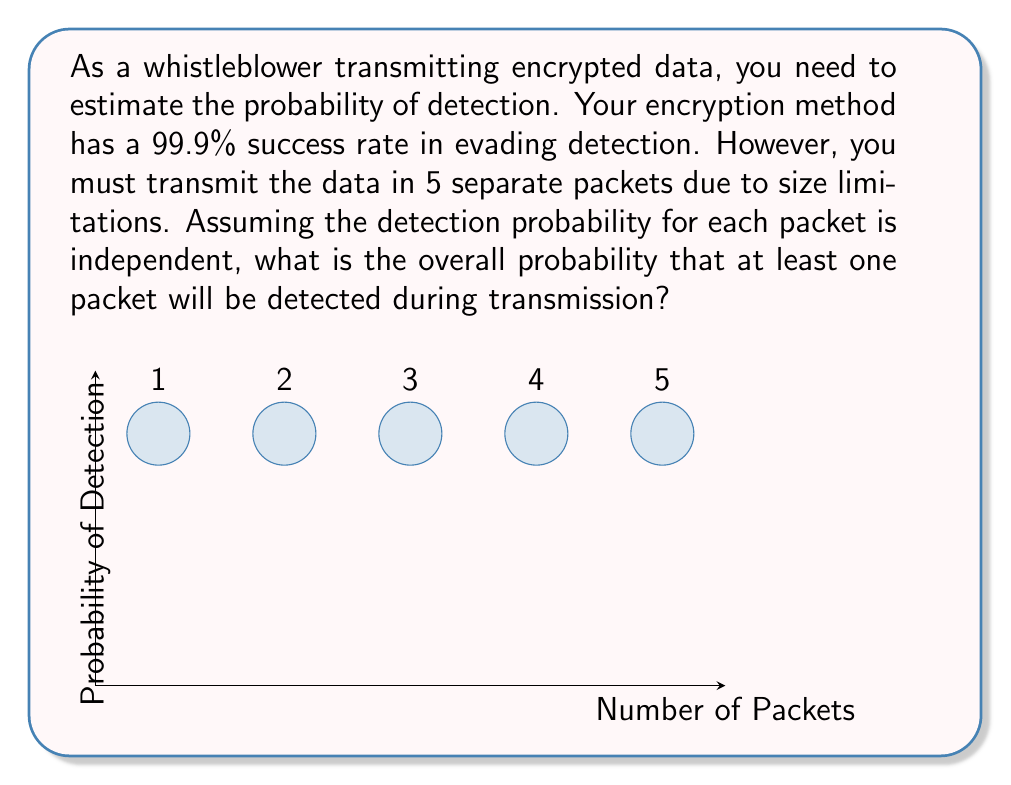Solve this math problem. Let's approach this step-by-step:

1) First, we need to calculate the probability of a single packet being detected. If the success rate of evading detection is 99.9%, then the probability of detection for a single packet is:

   $p = 1 - 0.999 = 0.001$ or 0.1%

2) Now, we need to find the probability that at least one packet out of 5 is detected. It's often easier to calculate the opposite event and then subtract from 1.

3) The opposite event is that no packets are detected. For this to happen, all 5 packets must evade detection.

4) The probability of all packets evading detection is:

   $P(\text{all evade}) = (0.999)^5$

5) Therefore, the probability that at least one packet is detected is:

   $P(\text{at least one detected}) = 1 - P(\text{all evade})$
   $= 1 - (0.999)^5$

6) Let's calculate this:
   
   $1 - (0.999)^5 = 1 - 0.995004995$
   $= 0.004995005$

7) Converting to a percentage:

   $0.004995005 * 100 = 0.4995005\%$

This means there's approximately a 0.5% chance that at least one packet will be detected during transmission.
Answer: $0.4995005\%$ 